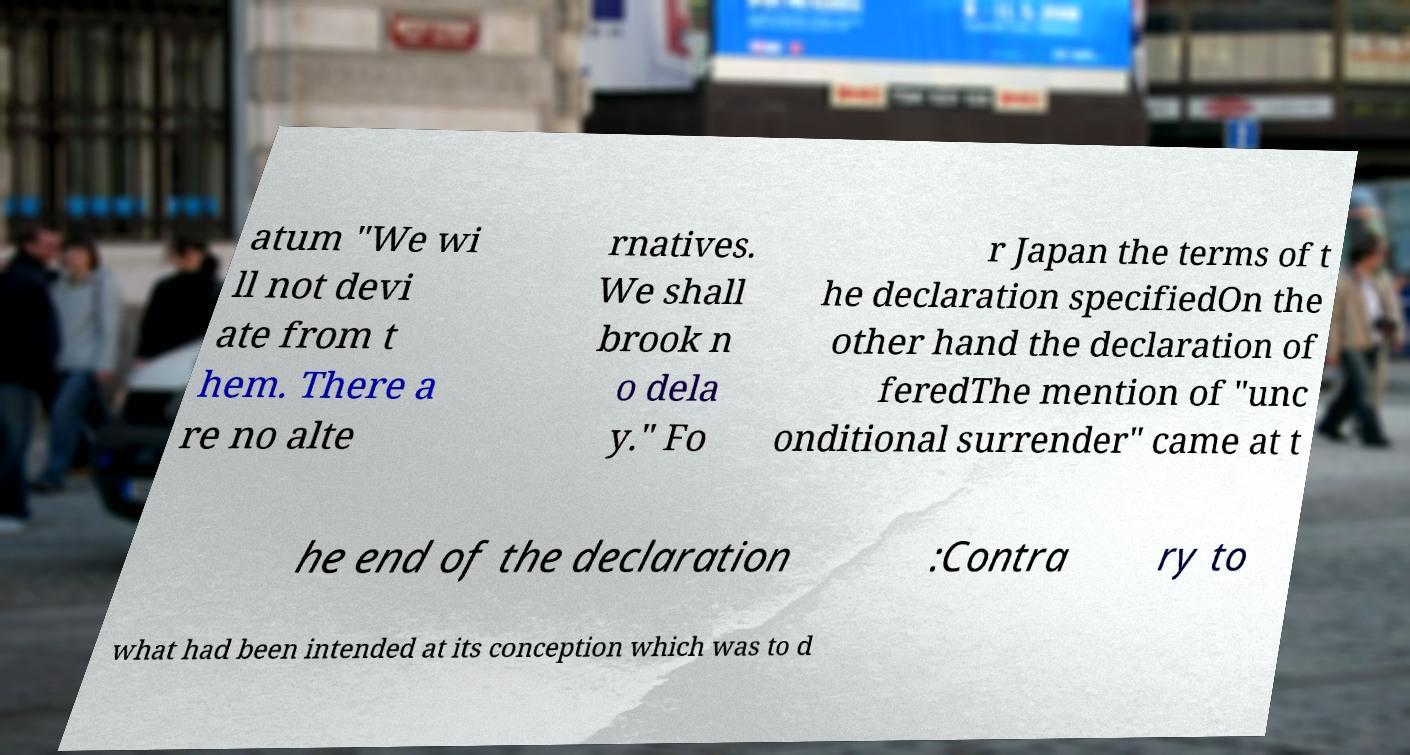I need the written content from this picture converted into text. Can you do that? atum "We wi ll not devi ate from t hem. There a re no alte rnatives. We shall brook n o dela y." Fo r Japan the terms of t he declaration specifiedOn the other hand the declaration of feredThe mention of "unc onditional surrender" came at t he end of the declaration :Contra ry to what had been intended at its conception which was to d 